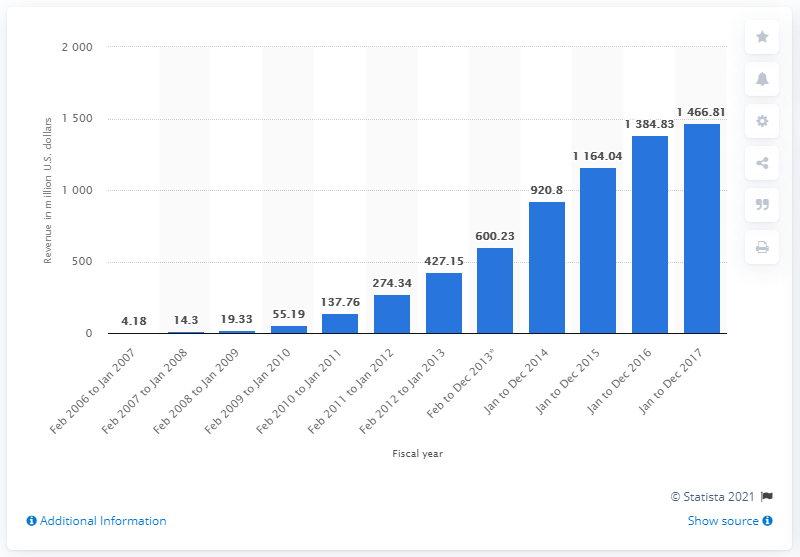Give some essential details in this illustration. In the fiscal year ending December 31, 2014, Pandora generated $920.8 million in revenue. 